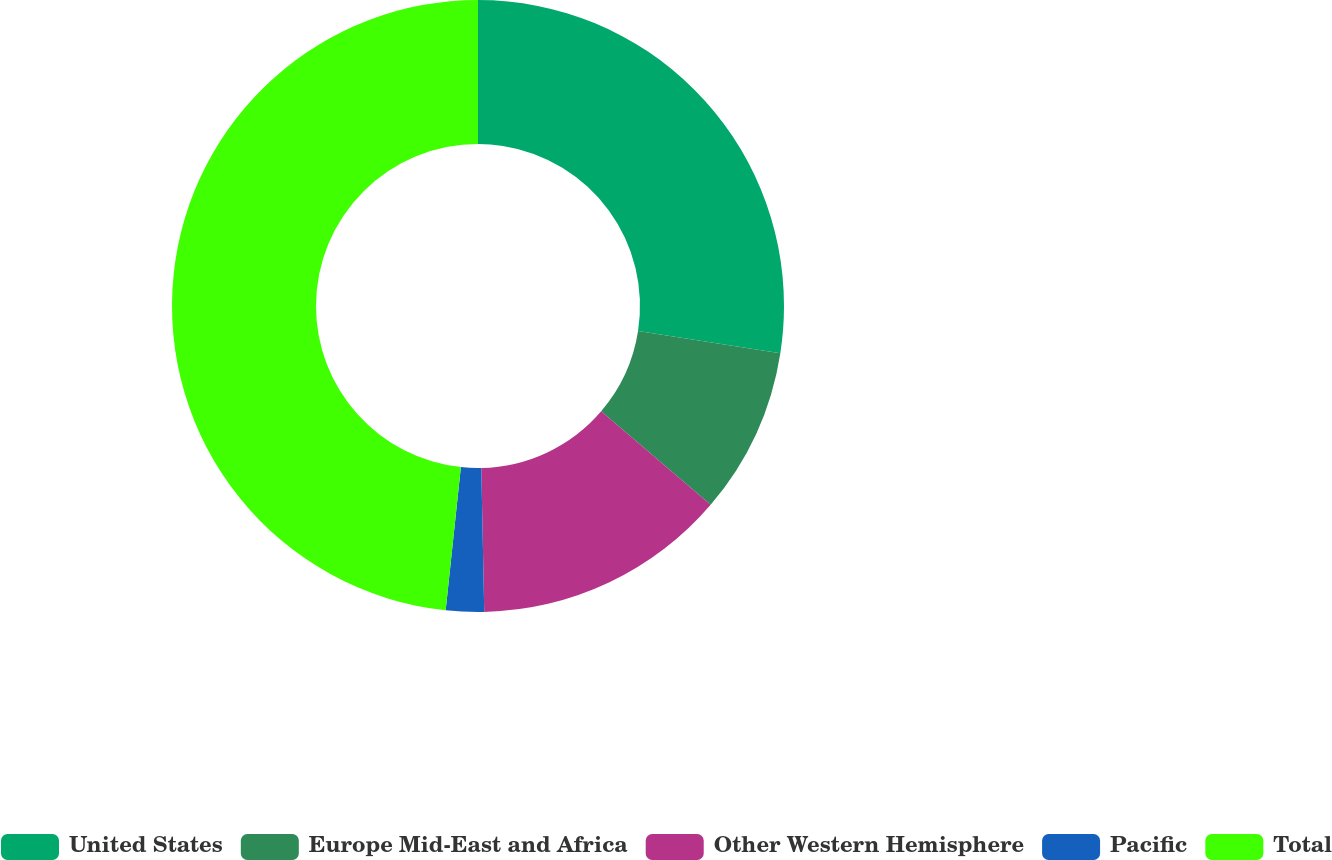Convert chart. <chart><loc_0><loc_0><loc_500><loc_500><pie_chart><fcel>United States<fcel>Europe Mid-East and Africa<fcel>Other Western Hemisphere<fcel>Pacific<fcel>Total<nl><fcel>27.46%<fcel>8.79%<fcel>13.42%<fcel>2.01%<fcel>48.31%<nl></chart> 